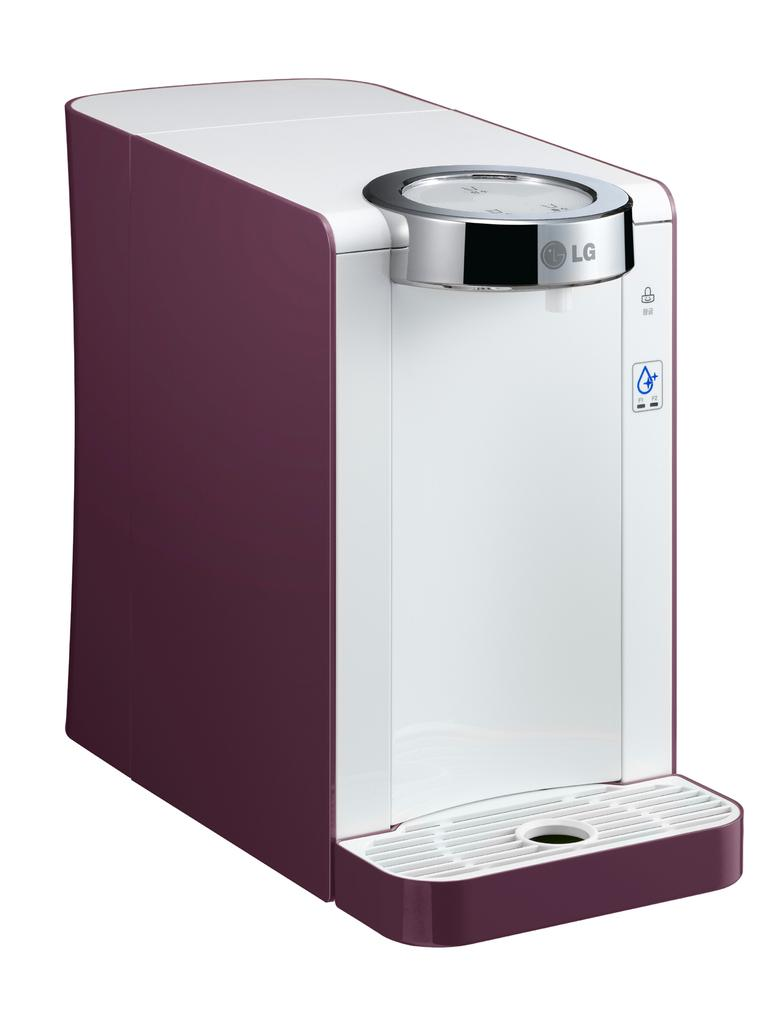<image>
Render a clear and concise summary of the photo. An Lg water dispenser is displayed in the color plum 